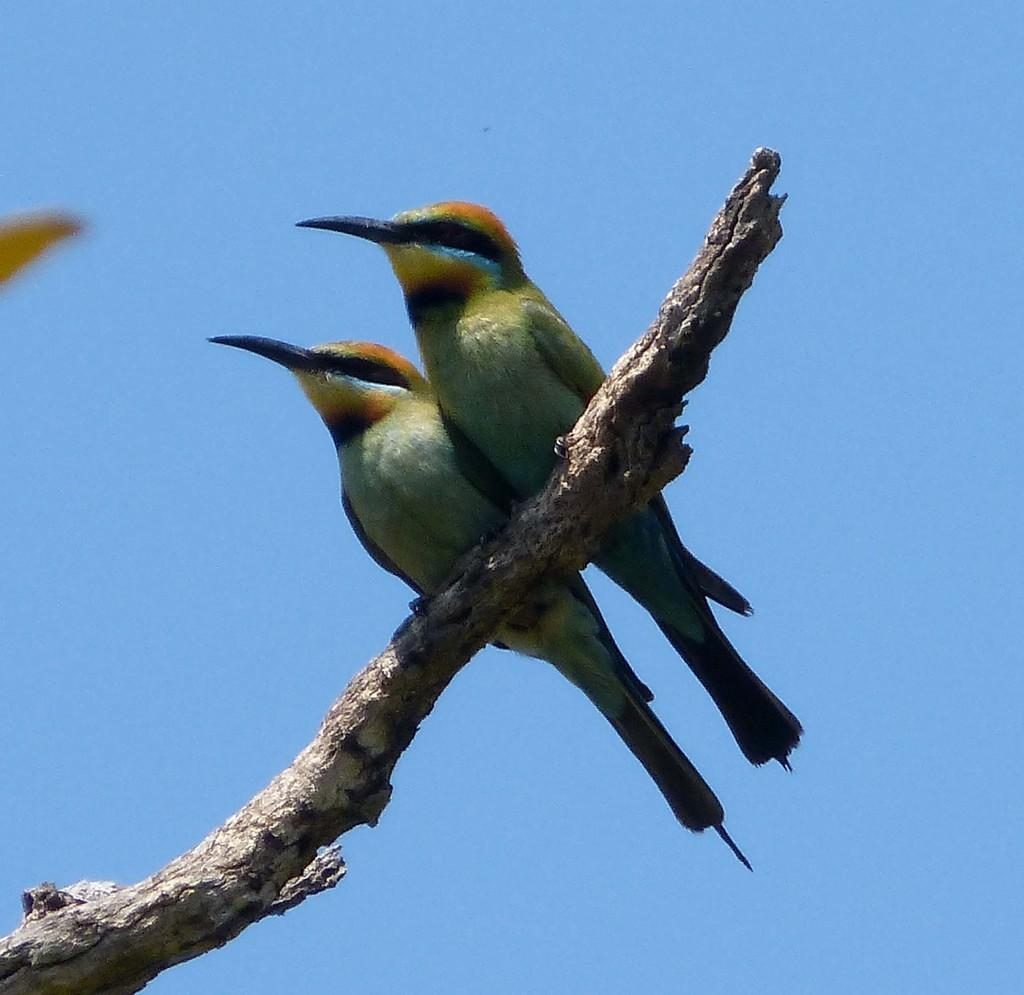How many birds are in the image? There are two birds in the image. What are the birds standing on? The birds are standing on a wooden branch. What can be seen in the background of the image? The sky is visible in the image. Where are the cherries hanging from in the image? There are no cherries present in the image. What type of faucet can be seen in the image? There is no faucet present in the image. 